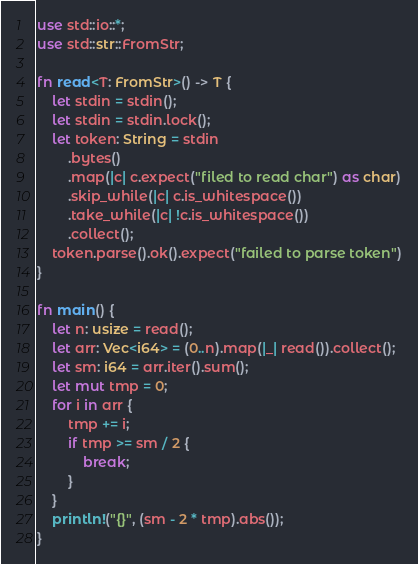Convert code to text. <code><loc_0><loc_0><loc_500><loc_500><_Rust_>use std::io::*;
use std::str::FromStr;

fn read<T: FromStr>() -> T {
    let stdin = stdin();
    let stdin = stdin.lock();
    let token: String = stdin
        .bytes()
        .map(|c| c.expect("filed to read char") as char)
        .skip_while(|c| c.is_whitespace())
        .take_while(|c| !c.is_whitespace())
        .collect();
    token.parse().ok().expect("failed to parse token")
}

fn main() {
    let n: usize = read();
    let arr: Vec<i64> = (0..n).map(|_| read()).collect();
    let sm: i64 = arr.iter().sum();
    let mut tmp = 0;
    for i in arr {
        tmp += i;
        if tmp >= sm / 2 {
            break;
        }
    }
    println!("{}", (sm - 2 * tmp).abs());
}</code> 